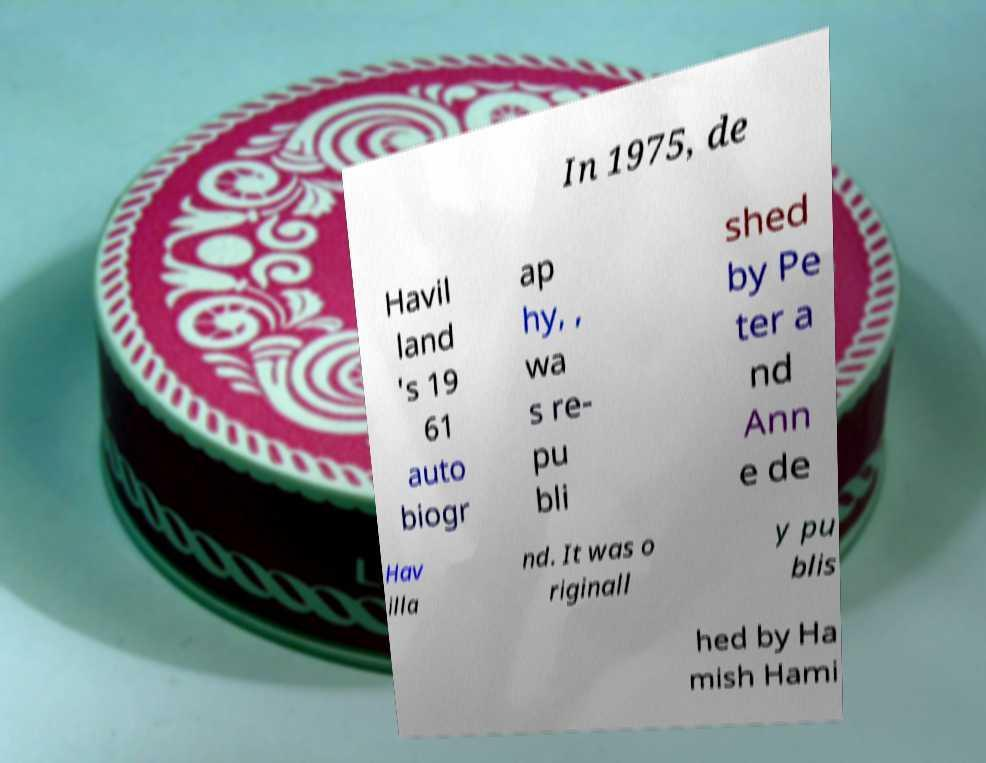Please identify and transcribe the text found in this image. In 1975, de Havil land 's 19 61 auto biogr ap hy, , wa s re- pu bli shed by Pe ter a nd Ann e de Hav illa nd. It was o riginall y pu blis hed by Ha mish Hami 